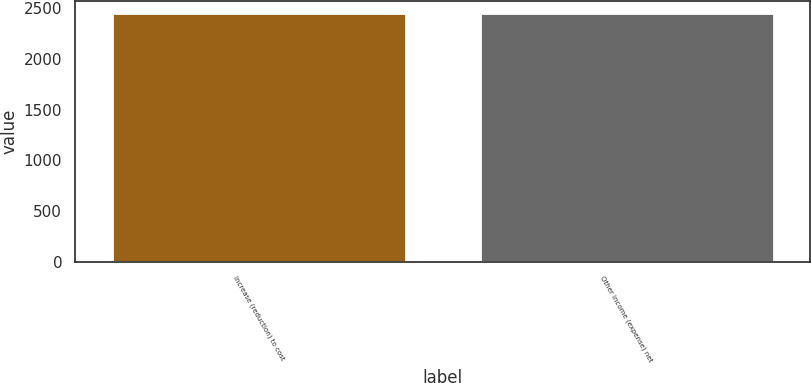Convert chart. <chart><loc_0><loc_0><loc_500><loc_500><bar_chart><fcel>Increase (reduction) to cost<fcel>Other income (expense) net<nl><fcel>2449<fcel>2449.1<nl></chart> 